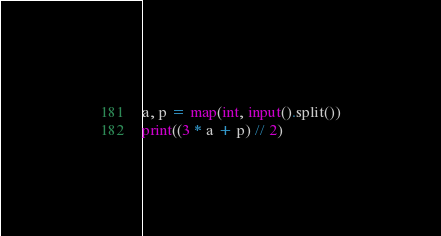Convert code to text. <code><loc_0><loc_0><loc_500><loc_500><_Python_>a, p = map(int, input().split())
print((3 * a + p) // 2)</code> 